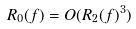<formula> <loc_0><loc_0><loc_500><loc_500>R _ { 0 } ( f ) = O ( R _ { 2 } ( f ) ^ { 3 } )</formula> 